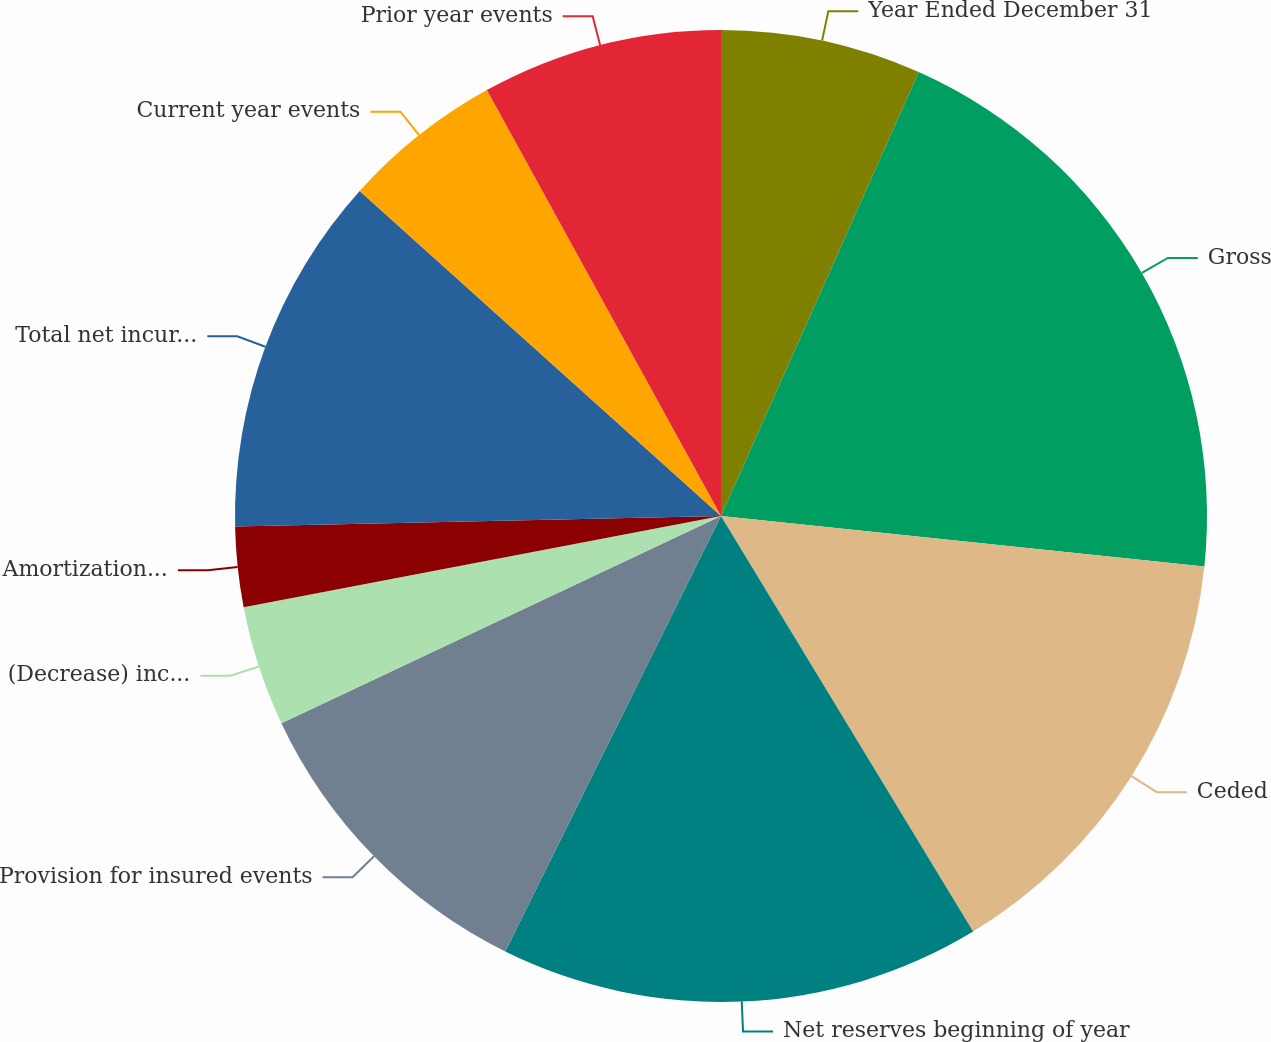<chart> <loc_0><loc_0><loc_500><loc_500><pie_chart><fcel>Year Ended December 31<fcel>Gross<fcel>Ceded<fcel>Net reserves beginning of year<fcel>Provision for insured events<fcel>(Decrease) increase in<fcel>Amortization of discount<fcel>Total net incurred (a)<fcel>Current year events<fcel>Prior year events<nl><fcel>6.67%<fcel>19.99%<fcel>14.66%<fcel>16.0%<fcel>10.67%<fcel>4.0%<fcel>2.67%<fcel>12.0%<fcel>5.34%<fcel>8.0%<nl></chart> 